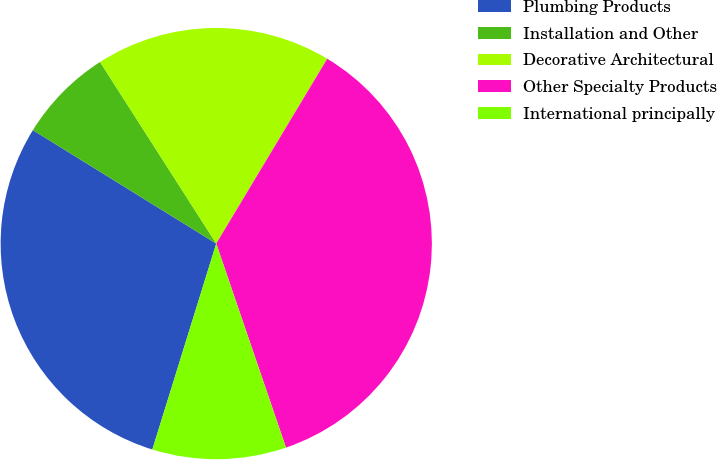Convert chart. <chart><loc_0><loc_0><loc_500><loc_500><pie_chart><fcel>Plumbing Products<fcel>Installation and Other<fcel>Decorative Architectural<fcel>Other Specialty Products<fcel>International principally<nl><fcel>29.03%<fcel>7.12%<fcel>17.67%<fcel>36.15%<fcel>10.03%<nl></chart> 